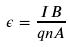Convert formula to latex. <formula><loc_0><loc_0><loc_500><loc_500>\epsilon = \frac { I B } { q n A }</formula> 